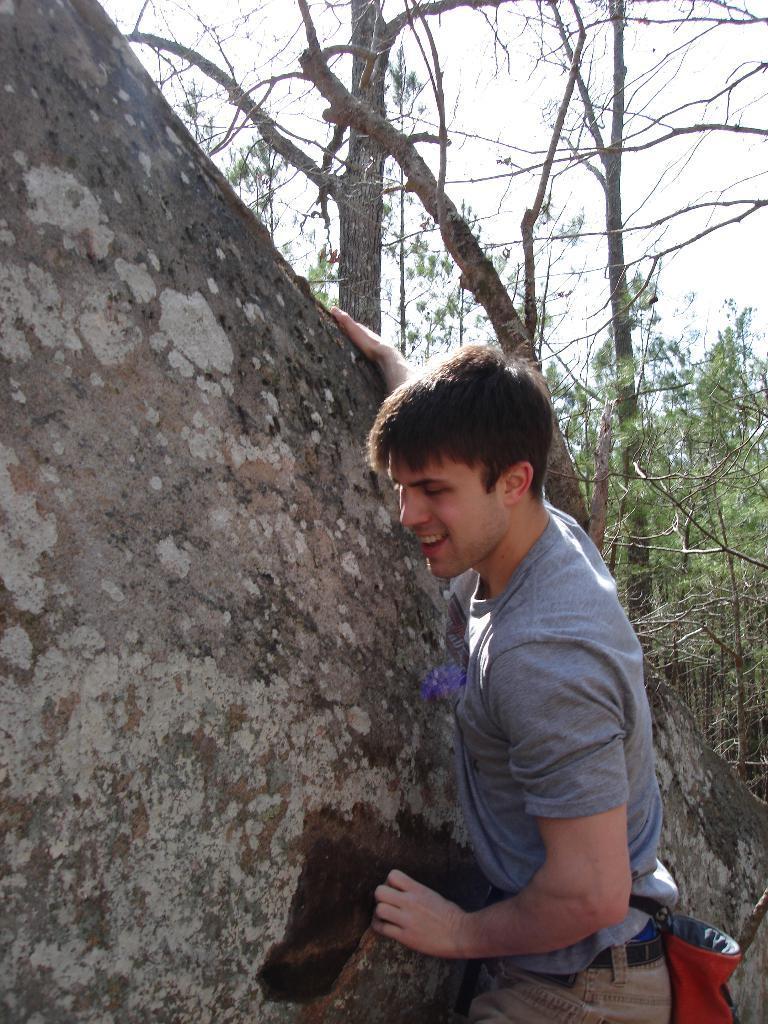How would you summarize this image in a sentence or two? In this image I can see a man and I can see he is wearing grey colour t shirt. In the background I can see number of trees and here I can see a brown colour thing. 